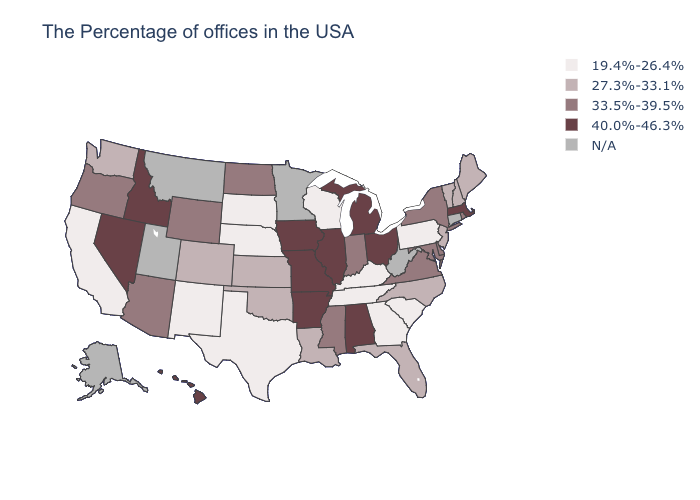Which states have the lowest value in the MidWest?
Quick response, please. Wisconsin, Nebraska, South Dakota. Among the states that border Maine , which have the highest value?
Short answer required. New Hampshire. Does North Carolina have the highest value in the South?
Be succinct. No. Name the states that have a value in the range 27.3%-33.1%?
Answer briefly. Maine, New Hampshire, Vermont, New Jersey, North Carolina, Florida, Louisiana, Kansas, Oklahoma, Colorado, Washington. What is the value of Arkansas?
Short answer required. 40.0%-46.3%. Does the map have missing data?
Short answer required. Yes. How many symbols are there in the legend?
Write a very short answer. 5. Is the legend a continuous bar?
Concise answer only. No. Is the legend a continuous bar?
Be succinct. No. What is the highest value in the USA?
Give a very brief answer. 40.0%-46.3%. Name the states that have a value in the range 19.4%-26.4%?
Short answer required. Pennsylvania, South Carolina, Georgia, Kentucky, Tennessee, Wisconsin, Nebraska, Texas, South Dakota, New Mexico, California. What is the value of Michigan?
Short answer required. 40.0%-46.3%. Does South Dakota have the highest value in the MidWest?
Be succinct. No. 